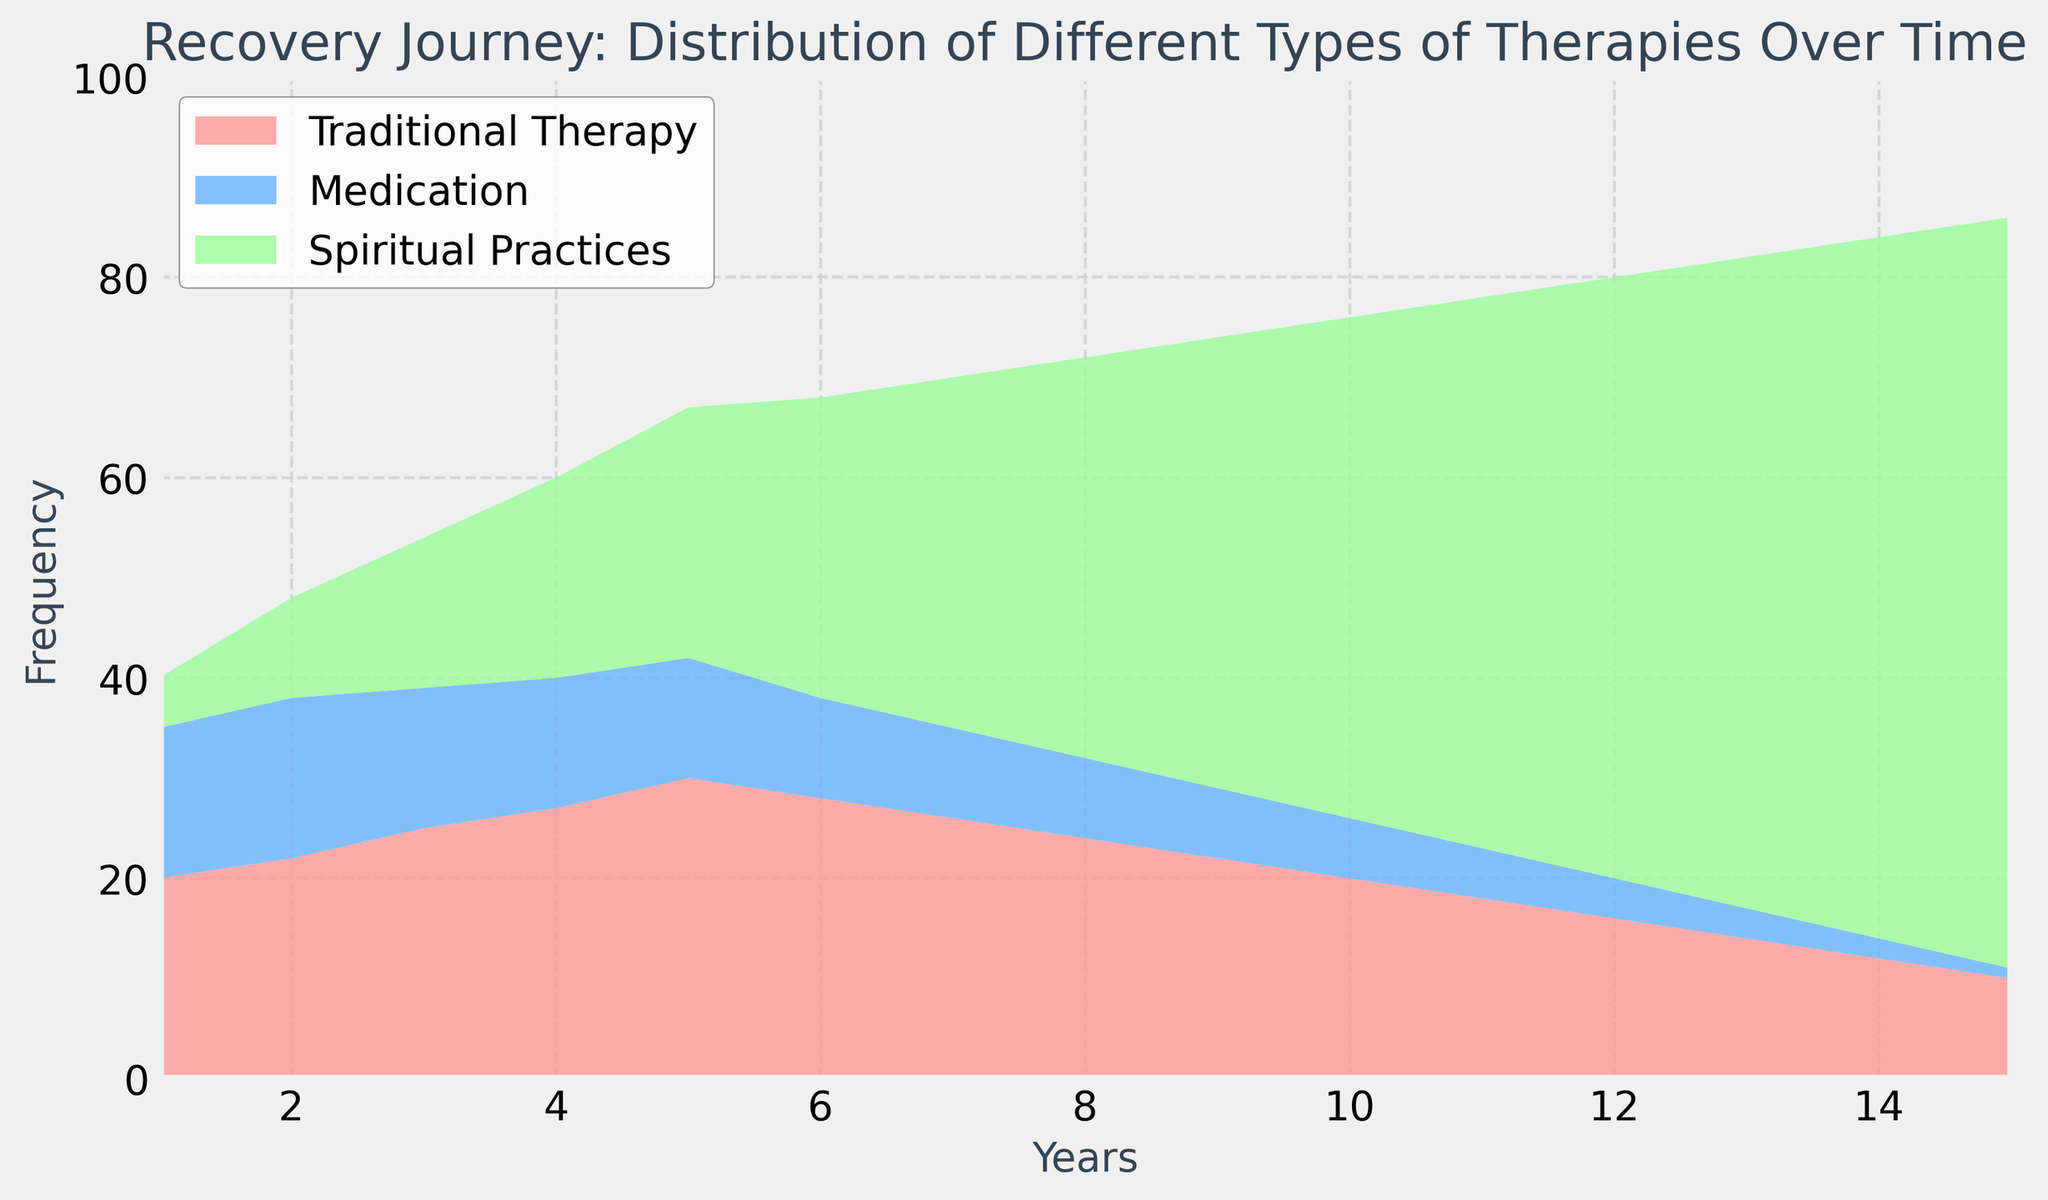What year did Spiritual Practices exceed Medication frequency for the first time? In Year 2, Medication frequency was 16 and Spiritual Practices frequency was 10. In Year 3, Medication frequency was 14 and Spiritual Practices frequency was 15. Therefore, the crossover occurred between Year 2 and Year 3.
Answer: Year 3 Which therapy type shows the most significant increase over the entire period? Traditional Therapy starts at 20 and drops to 10 by Year 15, showing a decrease. Medication starts at 15 and drops to 1, also showing a decrease. Spiritual Practices starts at 5 and increases to 75. Thus, Spiritual Practices shows the most significant increase.
Answer: Spiritual Practices What is the combined frequency of all therapy types in Year 5? Adding the frequencies in Year 5: Traditional Therapy (30) + Medication (12) + Spiritual Practices (25). Sum = 30 + 12 + 25 = 67.
Answer: 67 How does the frequency of Traditional Therapy change from Year 1 to Year 15? Traditional Therapy starts at 20 in Year 1 and decreases to 10 by Year 15. Therefore, it decreases by 10 units.
Answer: Decreases by 10 units Which therapy type had the lowest frequency at the beginning and the end of the period? At the beginning (Year 1), Spiritual Practices had a frequency of 5, which is the lowest compared to Traditional Therapy (20) and Medication (15). At the end (Year 15), Medication had the lowest frequency of 1 compared to Traditional Therapy (10) and Spiritual Practices (75).
Answer: Spiritual Practices (beginning), Medication (end) Identify the year where the sum of Traditional Therapy and Medication frequencies was the highest. Calculate the sum for each year and find the maximum: Year 1: 20 + 15 = 35, Year 2: 22 + 16 = 38 (Highest), Year 3: 25 + 14 = 39 ... Year 15: 10 + 1 = 11. Year 3 has the highest sum.
Answer: Year 3 In which years does the frequency of Traditional Therapy remain constant? Traditional Therapy frequency was constant between Year 5 (30) and Year 6 (28), then from Year 11 (18) to Year 12 (16), and from Year 13 (14) to Year 14 (12) with minor delay continuity.
Answer: No years How did the proportion of Spiritual Practices compare to the combined total of other therapies in Year 10? In Year 10, the frequency of Spiritual Practices is 50, Traditional Therapy is 20, and Medication is 6. Sum of other therapies: 20 + 6 = 26. Spiritual Practices frequency = 50. Thus, Spiritual Practices exceed the combined total of other therapies in Year 10.
Answer: Exceeding From Year 1 to Year 15, which therapy has the least total reduction in frequency? Traditional Therapy reduced from 20 to 10 (decrease by 10 units), Medication reduced from 15 to 1 (decrease by 14 units), and Spiritual Practices increased from 5 to 75. Thus, Traditional Therapy has the least reduction.
Answer: Traditional Therapy 